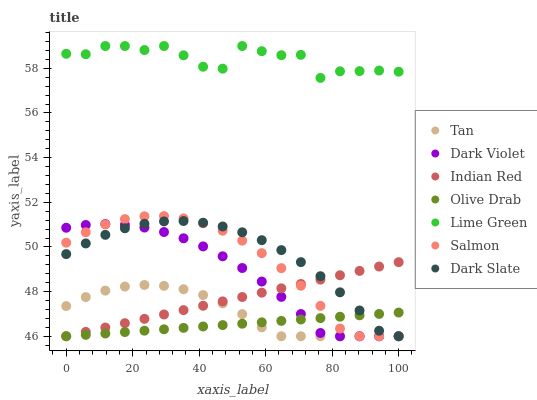Does Olive Drab have the minimum area under the curve?
Answer yes or no. Yes. Does Lime Green have the maximum area under the curve?
Answer yes or no. Yes. Does Dark Violet have the minimum area under the curve?
Answer yes or no. No. Does Dark Violet have the maximum area under the curve?
Answer yes or no. No. Is Olive Drab the smoothest?
Answer yes or no. Yes. Is Lime Green the roughest?
Answer yes or no. Yes. Is Dark Violet the smoothest?
Answer yes or no. No. Is Dark Violet the roughest?
Answer yes or no. No. Does Salmon have the lowest value?
Answer yes or no. Yes. Does Lime Green have the lowest value?
Answer yes or no. No. Does Lime Green have the highest value?
Answer yes or no. Yes. Does Dark Violet have the highest value?
Answer yes or no. No. Is Indian Red less than Lime Green?
Answer yes or no. Yes. Is Lime Green greater than Dark Violet?
Answer yes or no. Yes. Does Dark Slate intersect Dark Violet?
Answer yes or no. Yes. Is Dark Slate less than Dark Violet?
Answer yes or no. No. Is Dark Slate greater than Dark Violet?
Answer yes or no. No. Does Indian Red intersect Lime Green?
Answer yes or no. No. 